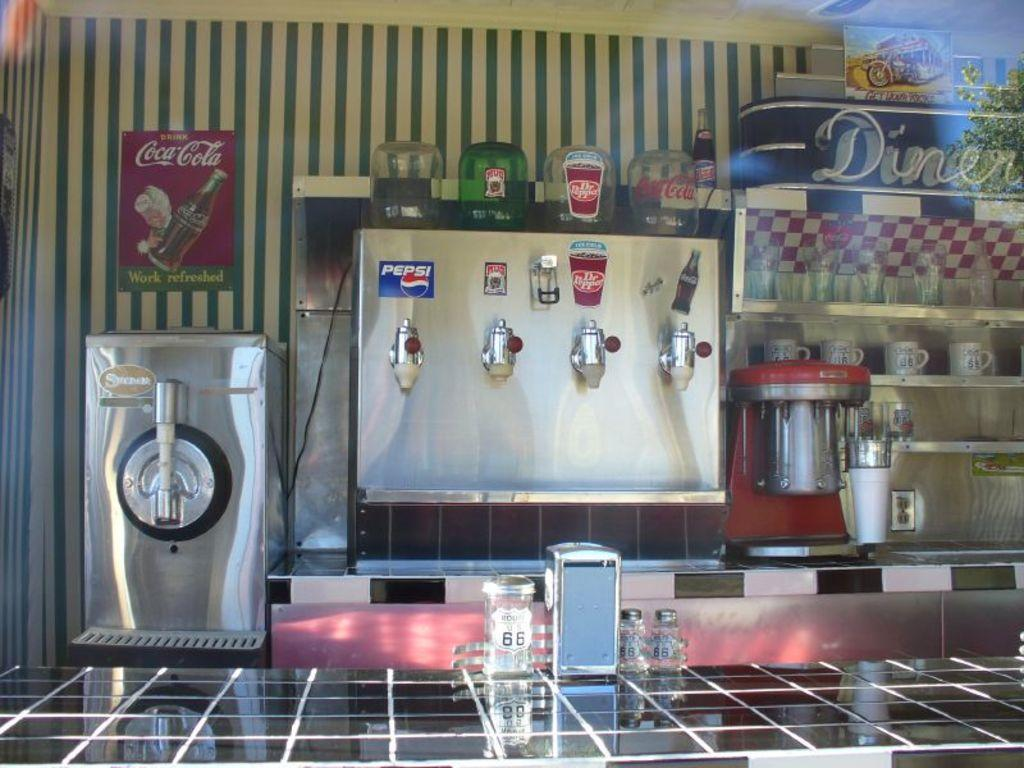<image>
Offer a succinct explanation of the picture presented. A fountain machine has signs for Pepsi and Dr. Pepper among others. 